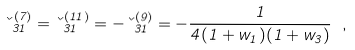<formula> <loc_0><loc_0><loc_500><loc_500>\kappa _ { 3 1 } ^ { ( 7 ) } = \kappa _ { 3 1 } ^ { ( 1 1 ) } = - \kappa _ { 3 1 } ^ { ( 9 ) } = - \frac { 1 } { 4 ( 1 + w _ { 1 } ) ( 1 + w _ { 3 } ) } \ ,</formula> 